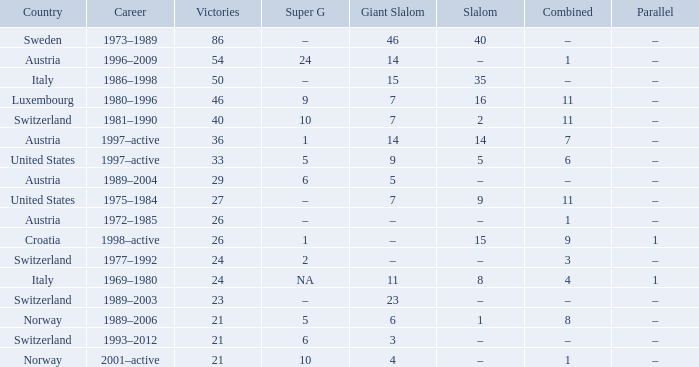What austrian super g skier holds 26 victories to their name? –. 